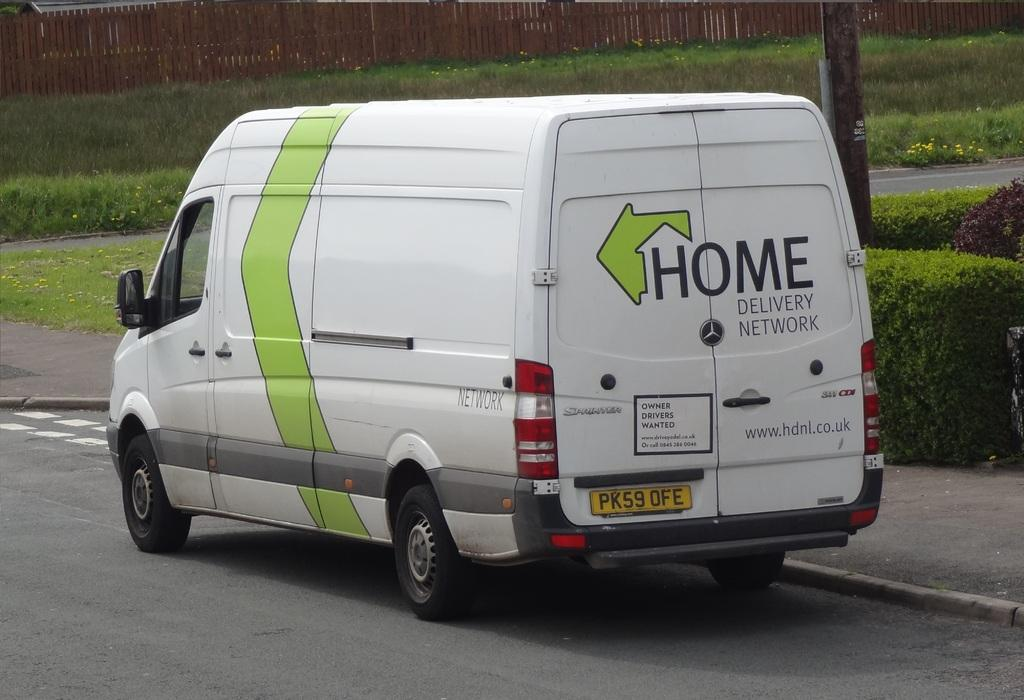<image>
Write a terse but informative summary of the picture. White van which says HOME on the back. 